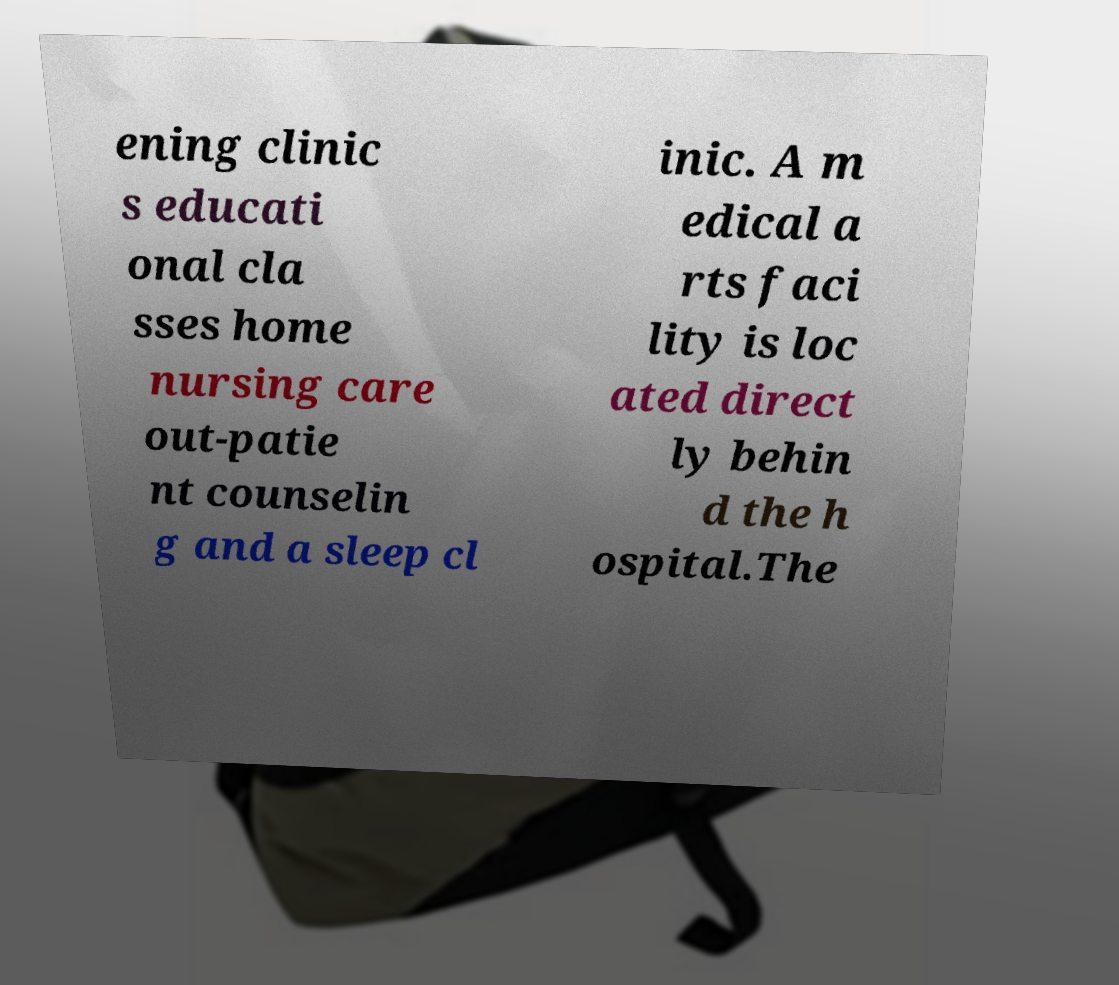For documentation purposes, I need the text within this image transcribed. Could you provide that? ening clinic s educati onal cla sses home nursing care out-patie nt counselin g and a sleep cl inic. A m edical a rts faci lity is loc ated direct ly behin d the h ospital.The 